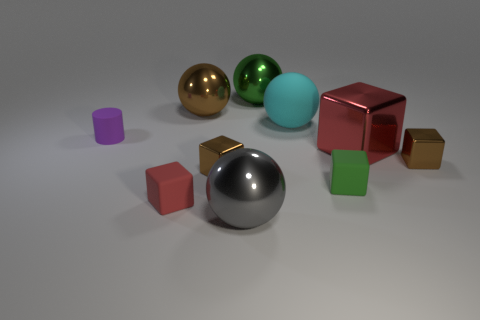There is a thing that is the same color as the big metallic cube; what is its shape?
Your response must be concise. Cube. There is another rubber object that is the same shape as the big gray object; what color is it?
Ensure brevity in your answer.  Cyan. What number of large cubes are made of the same material as the small purple object?
Ensure brevity in your answer.  0. Is the size of the cyan thing the same as the green metallic thing?
Keep it short and to the point. Yes. Are there any other things that have the same color as the large rubber thing?
Give a very brief answer. No. The large metal object that is in front of the small rubber cylinder and behind the tiny green object has what shape?
Offer a very short reply. Cube. There is a red object behind the green cube; what is its size?
Your answer should be very brief. Large. There is a green thing that is in front of the shiny cube left of the small green matte cube; what number of purple rubber things are left of it?
Offer a terse response. 1. There is a purple matte thing; are there any small rubber things left of it?
Make the answer very short. No. How many other things are there of the same size as the gray metallic ball?
Keep it short and to the point. 4. 